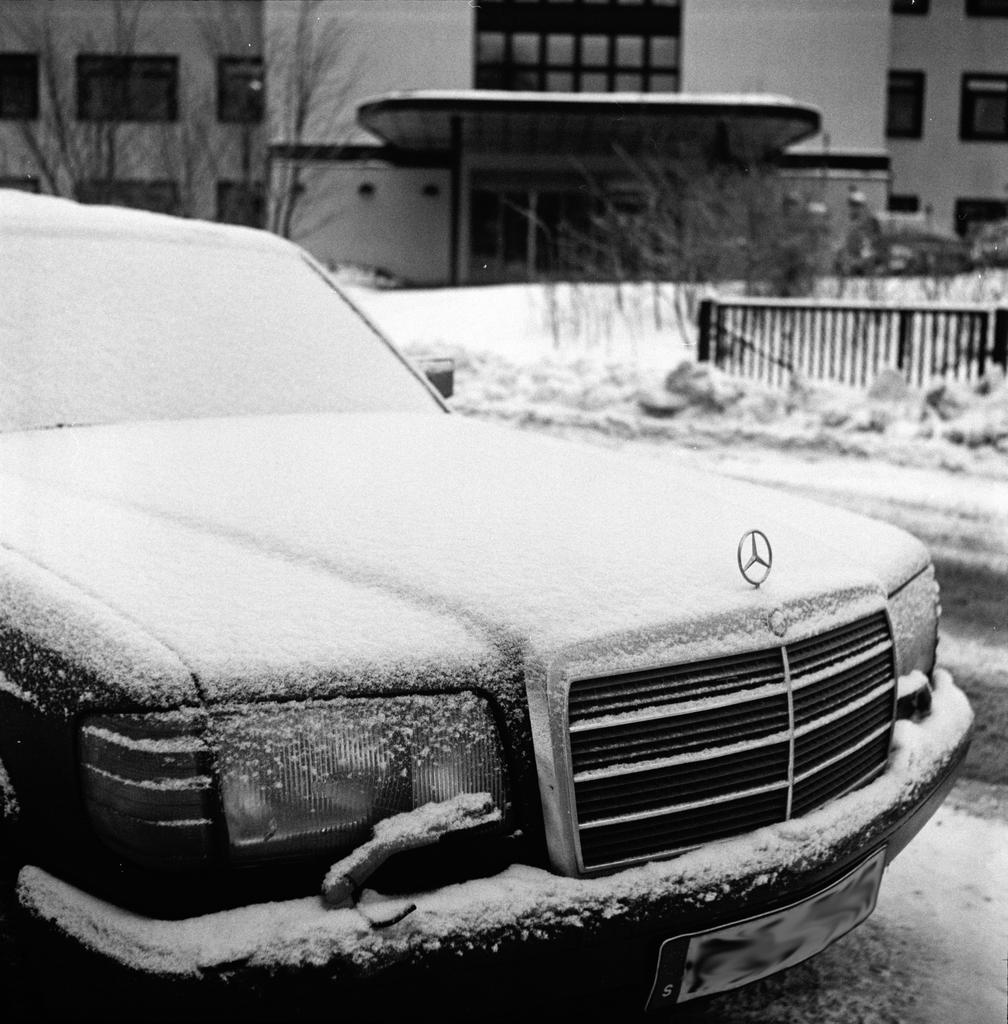How would you summarize this image in a sentence or two? This is a black and white image where we can see snow on the car. The background of the image is slightly blurred, where we can see the road covered with snow, trees and a building. 